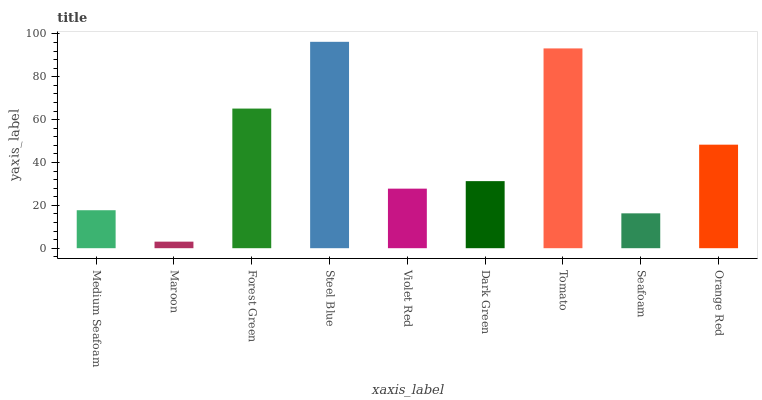Is Maroon the minimum?
Answer yes or no. Yes. Is Steel Blue the maximum?
Answer yes or no. Yes. Is Forest Green the minimum?
Answer yes or no. No. Is Forest Green the maximum?
Answer yes or no. No. Is Forest Green greater than Maroon?
Answer yes or no. Yes. Is Maroon less than Forest Green?
Answer yes or no. Yes. Is Maroon greater than Forest Green?
Answer yes or no. No. Is Forest Green less than Maroon?
Answer yes or no. No. Is Dark Green the high median?
Answer yes or no. Yes. Is Dark Green the low median?
Answer yes or no. Yes. Is Forest Green the high median?
Answer yes or no. No. Is Seafoam the low median?
Answer yes or no. No. 